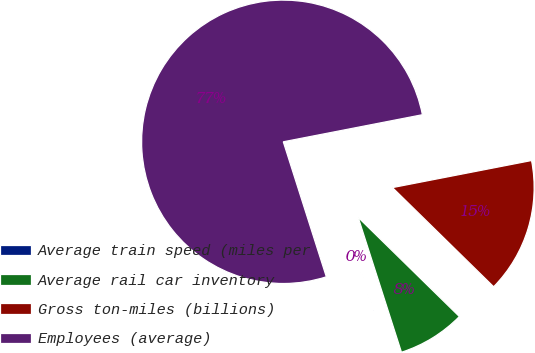<chart> <loc_0><loc_0><loc_500><loc_500><pie_chart><fcel>Average train speed (miles per<fcel>Average rail car inventory<fcel>Gross ton-miles (billions)<fcel>Employees (average)<nl><fcel>0.03%<fcel>7.72%<fcel>15.4%<fcel>76.85%<nl></chart> 